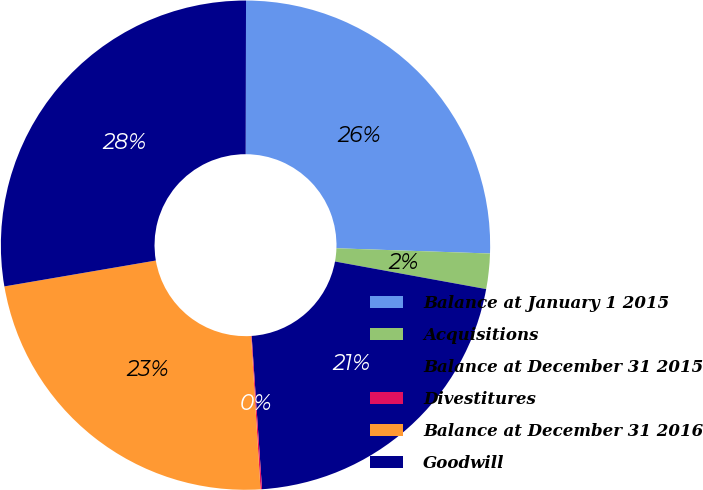Convert chart to OTSL. <chart><loc_0><loc_0><loc_500><loc_500><pie_chart><fcel>Balance at January 1 2015<fcel>Acquisitions<fcel>Balance at December 31 2015<fcel>Divestitures<fcel>Balance at December 31 2016<fcel>Goodwill<nl><fcel>25.51%<fcel>2.33%<fcel>21.05%<fcel>0.1%<fcel>23.28%<fcel>27.73%<nl></chart> 